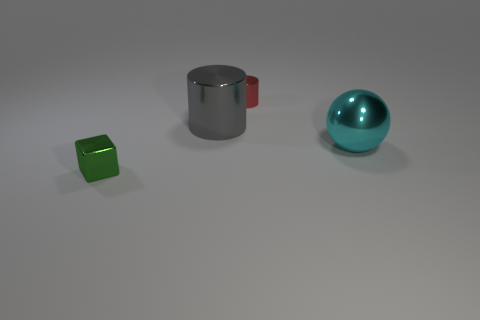Are there any other things that are the same shape as the large cyan object?
Provide a succinct answer. No. How big is the shiny thing behind the big gray thing?
Your answer should be compact. Small. Is there any other thing of the same color as the big metal cylinder?
Provide a short and direct response. No. Is there a tiny thing that is behind the tiny shiny thing that is in front of the thing behind the large metal cylinder?
Ensure brevity in your answer.  Yes. How many cylinders are cyan objects or small objects?
Provide a short and direct response. 1. What is the shape of the object on the right side of the tiny shiny object on the right side of the tiny green metal cube?
Give a very brief answer. Sphere. How big is the green object in front of the small shiny object behind the thing in front of the cyan metal ball?
Ensure brevity in your answer.  Small. Is the gray cylinder the same size as the cube?
Give a very brief answer. No. What number of objects are red shiny things or small red blocks?
Your answer should be compact. 1. How big is the green metallic thing in front of the small thing that is to the right of the small green object?
Ensure brevity in your answer.  Small. 